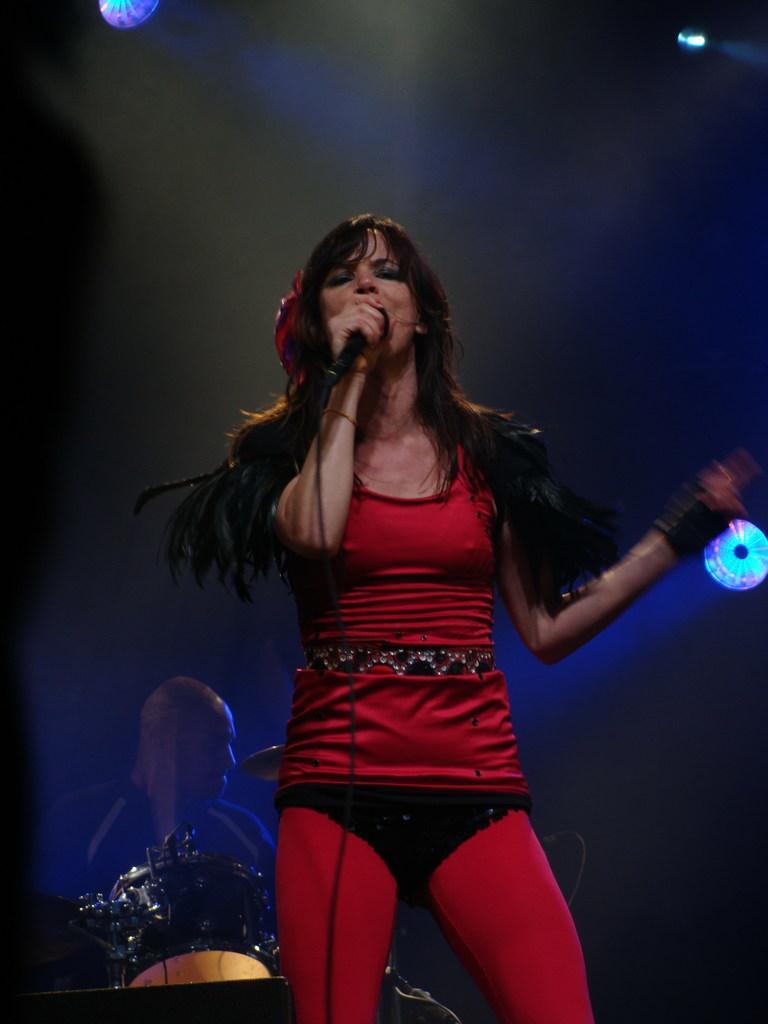Can you describe this image briefly? In this picture we can see a woman standing and holding a mic with her hand and at the back of her we can see a man, drums, lights and in the background it is dark. 